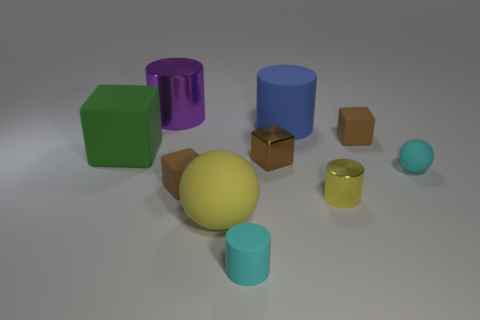Subtract all green balls. Subtract all red cylinders. How many balls are left? 2 Subtract all blue balls. How many yellow cubes are left? 0 Add 4 small objects. How many purples exist? 0 Subtract all large matte cylinders. Subtract all tiny cylinders. How many objects are left? 7 Add 8 matte balls. How many matte balls are left? 10 Add 6 green metallic things. How many green metallic things exist? 6 Subtract all green cubes. How many cubes are left? 3 Subtract all cyan rubber cylinders. How many cylinders are left? 3 Subtract 1 green cubes. How many objects are left? 9 Subtract all cubes. How many objects are left? 6 